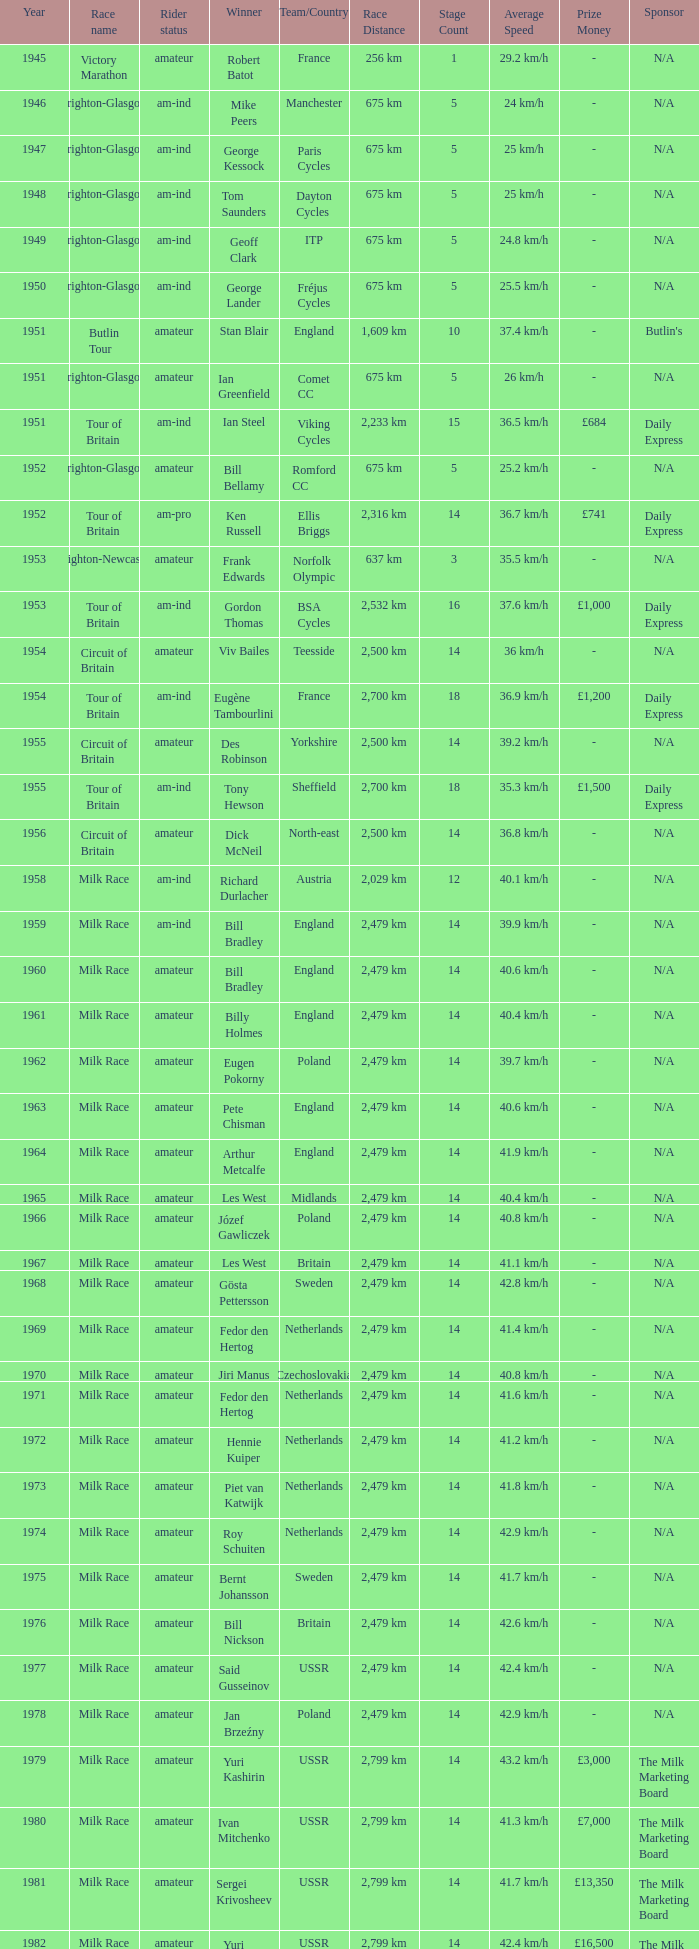Who was the winner in 1973 with an amateur rider status? Piet van Katwijk. 